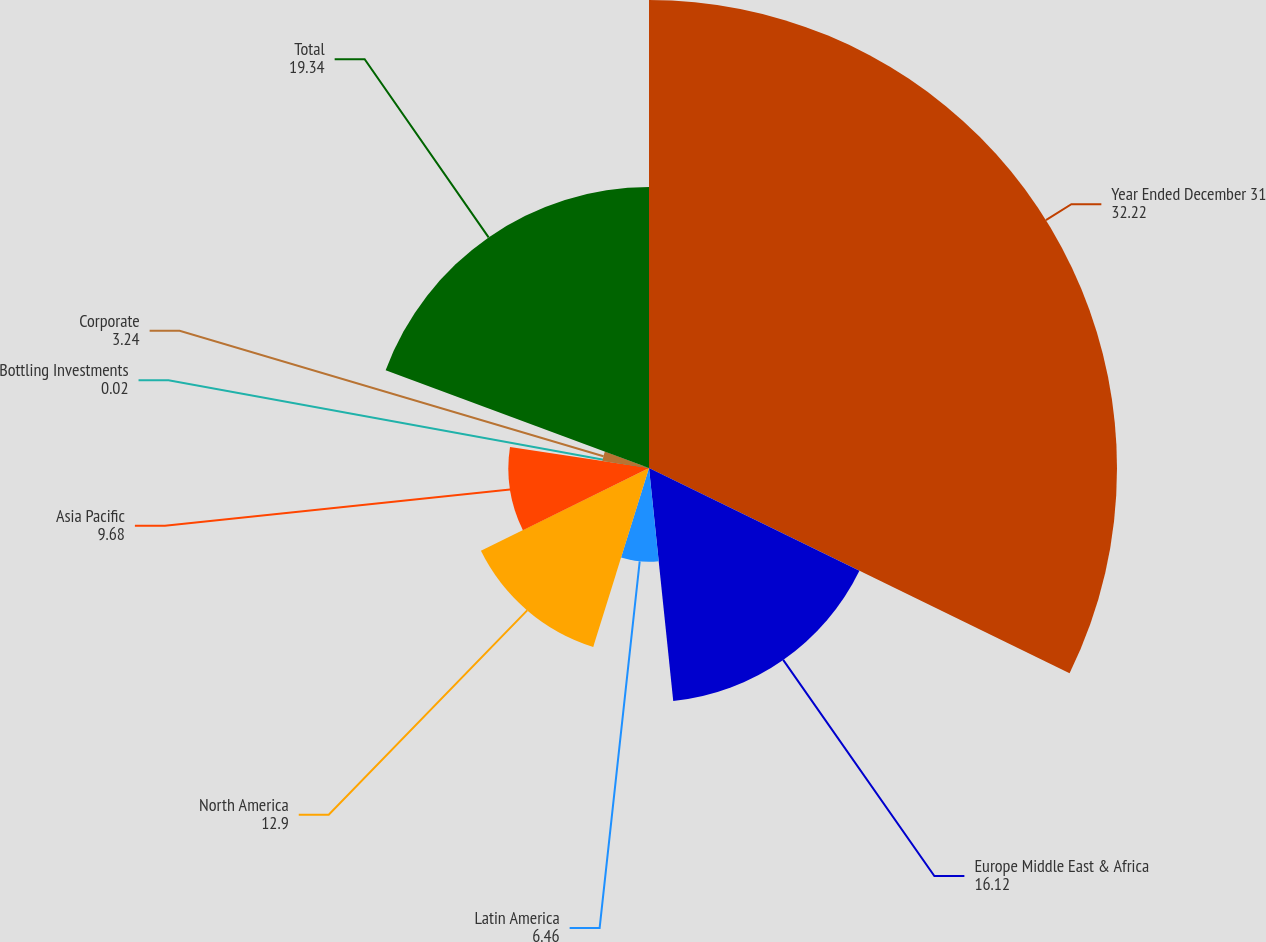Convert chart to OTSL. <chart><loc_0><loc_0><loc_500><loc_500><pie_chart><fcel>Year Ended December 31<fcel>Europe Middle East & Africa<fcel>Latin America<fcel>North America<fcel>Asia Pacific<fcel>Bottling Investments<fcel>Corporate<fcel>Total<nl><fcel>32.22%<fcel>16.12%<fcel>6.46%<fcel>12.9%<fcel>9.68%<fcel>0.02%<fcel>3.24%<fcel>19.34%<nl></chart> 